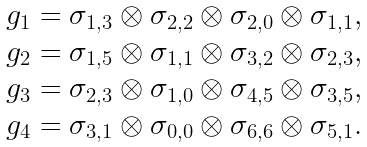Convert formula to latex. <formula><loc_0><loc_0><loc_500><loc_500>\begin{array} { l } g _ { 1 } = \sigma _ { 1 , 3 } \otimes \sigma _ { 2 , 2 } \otimes \sigma _ { 2 , 0 } \otimes \sigma _ { 1 , 1 } , \\ g _ { 2 } = \sigma _ { 1 , 5 } \otimes \sigma _ { 1 , 1 } \otimes \sigma _ { 3 , 2 } \otimes \sigma _ { 2 , 3 } , \\ g _ { 3 } = \sigma _ { 2 , 3 } \otimes \sigma _ { 1 , 0 } \otimes \sigma _ { 4 , 5 } \otimes \sigma _ { 3 , 5 } , \\ g _ { 4 } = \sigma _ { 3 , 1 } \otimes \sigma _ { 0 , 0 } \otimes \sigma _ { 6 , 6 } \otimes \sigma _ { 5 , 1 } . \end{array}</formula> 